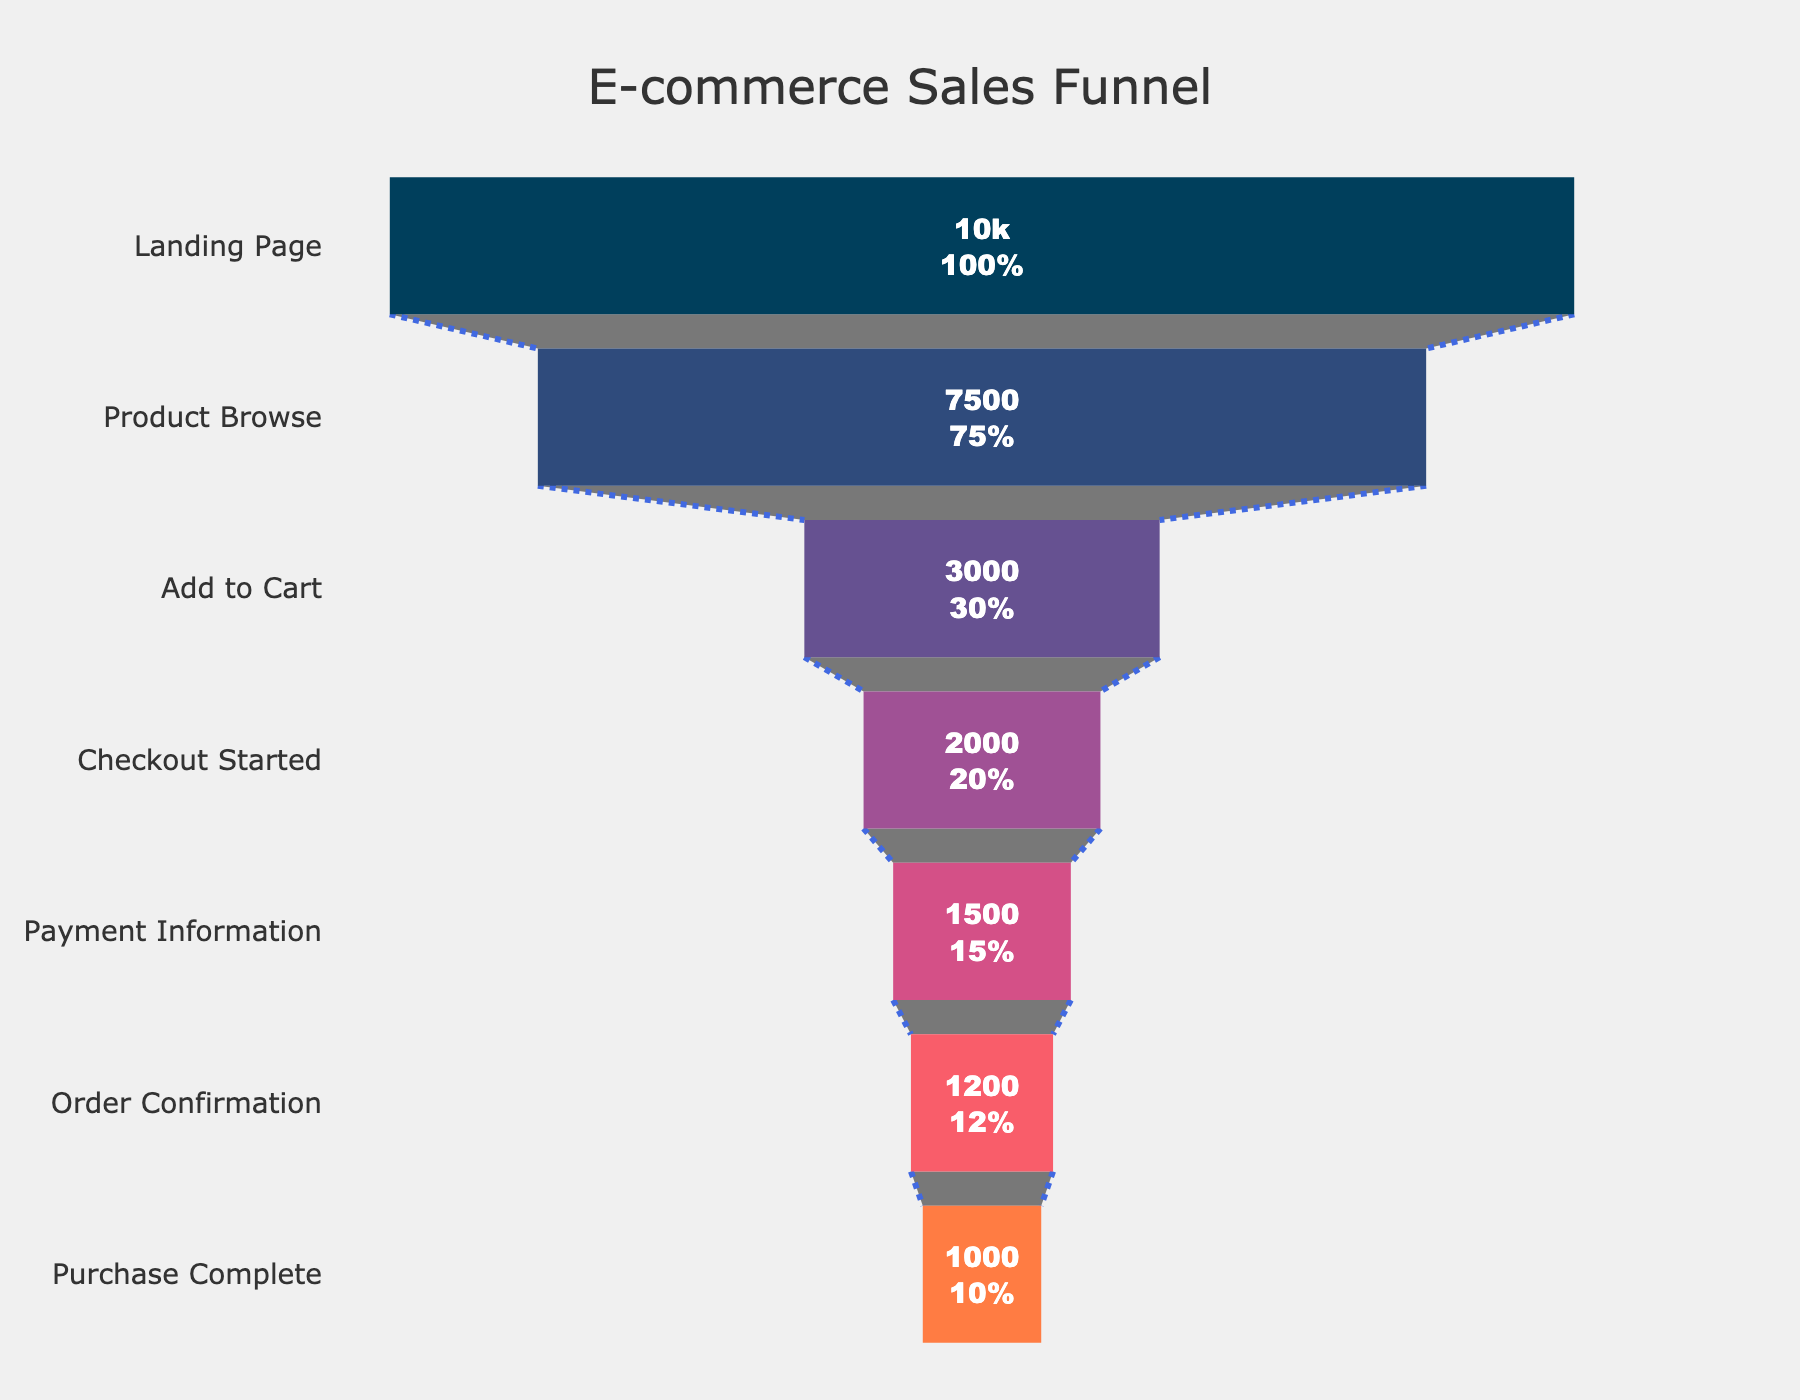What's the title of the funnel chart? The title is the text at the top of the funnel chart in larger font size compared to other text elements. In this case, it clearly states "E-commerce Sales Funnel."
Answer: E-commerce Sales Funnel How many stages are there in the funnel? Count the number of distinct stages displayed along the y-axis of the funnel chart. The stages are "Landing Page," "Product Browse," "Add to Cart," "Checkout Started," "Payment Information," "Order Confirmation," and "Purchase Complete." Thus, there are 7 stages.
Answer: 7 What is the number of visitors at the Product Browse stage? Identify the value associated with the "Product Browse" stage in the funnel chart. The chart shows that there are 7,500 visitors.
Answer: 7,500 How many visitors were lost between the Add to Cart and Checkout Started stages? Subtract the number of visitors at the "Checkout Started" stage from the number at the "Add to Cart" stage. 3,000 (Add to Cart) - 2,000 (Checkout Started) = 1,000 visitors lost.
Answer: 1,000 Which stage has the highest number of visitors? Compare the values for each stage displayed in the funnel chart. The stage with the highest number is the "Landing Page" with 10,000 visitors.
Answer: Landing Page Which stage has the lowest conversion rate compared to the previous stage? Calculate the conversion rate between each consecutive stage by dividing the number of visitors in the latter stage by the number in the former stage, then identify the lowest value.
- Landing Page to Product Browse: 7,500 / 10,000 = 75%
- Product Browse to Add to Cart: 3,000 / 7,500 = 40%
- Add to Cart to Checkout Started: 2,000 / 3,000 = 66.7%
- Checkout Started to Payment Information: 1,500 / 2,000 = 75%
- Payment Information to Order Confirmation: 1,200 / 1,500 = 80%
- Order Confirmation to Purchase Complete: 1,000 / 1,200 = 83.3%
The lowest conversion rate is from Product Browse to Add to Cart at 40%.
Answer: Product Browse to Add to Cart What percentage of visitors complete a purchase out of those who reached the Payment Information stage? Calculate the percentage by dividing the number of visitors who completed the purchase by those who reached the Payment Information stage and multiply by 100. 
1,000 (Purchase Complete) / 1,500 (Payment Information) * 100 = 66.67%
Answer: 66.67% What is the total number of visitors lost from the Landing Page to the completed purchase? Subtract the number of visitors at the "Purchase Complete" stage from the number at the "Landing Page" stage. 
10,000 (Landing Page) - 1,000 (Purchase Complete) = 9,000 visitors lost.
Answer: 9,000 Which stage shows a retention rate greater than 50% compared to the previous stage? Calculate the retention rates for each stage transition and compare them to 50%.
- Landing Page to Product Browse: 7,500 / 10,000 = 75%
- Product Browse to Add to Cart: 3,000 / 7,500 = 40%
- Add to Cart to Checkout Started: 2,000 / 3,000 = 66.7%
- Checkout Started to Payment Information: 1,500 / 2,000 = 75%
- Payment Information to Order Confirmation: 1,200 / 1,500 = 80%
- Order Confirmation to Purchase Complete: 1,000 / 1,200 = 83.3%
Stages with retention rates greater than 50% are: Landing Page to Product Browse, Add to Cart to Checkout Started, Checkout Started to Payment Information, Payment Information to Order Confirmation, and Order Confirmation to Purchase Complete.
Answer: Landing Page to Product Browse, Add to Cart to Checkout Started, Checkout Started to Payment Information, Payment Information to Order Confirmation, Order Confirmation to Purchase Complete 